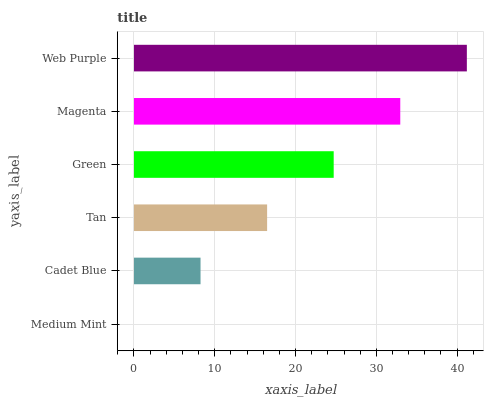Is Medium Mint the minimum?
Answer yes or no. Yes. Is Web Purple the maximum?
Answer yes or no. Yes. Is Cadet Blue the minimum?
Answer yes or no. No. Is Cadet Blue the maximum?
Answer yes or no. No. Is Cadet Blue greater than Medium Mint?
Answer yes or no. Yes. Is Medium Mint less than Cadet Blue?
Answer yes or no. Yes. Is Medium Mint greater than Cadet Blue?
Answer yes or no. No. Is Cadet Blue less than Medium Mint?
Answer yes or no. No. Is Green the high median?
Answer yes or no. Yes. Is Tan the low median?
Answer yes or no. Yes. Is Tan the high median?
Answer yes or no. No. Is Green the low median?
Answer yes or no. No. 